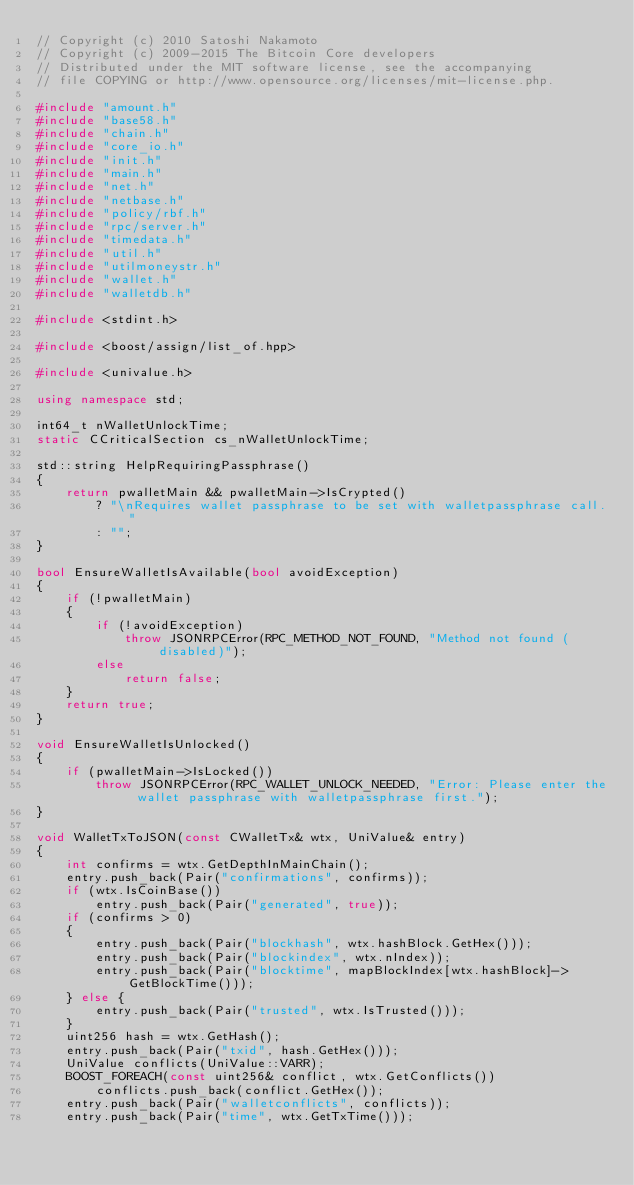<code> <loc_0><loc_0><loc_500><loc_500><_C++_>// Copyright (c) 2010 Satoshi Nakamoto
// Copyright (c) 2009-2015 The Bitcoin Core developers
// Distributed under the MIT software license, see the accompanying
// file COPYING or http://www.opensource.org/licenses/mit-license.php.

#include "amount.h"
#include "base58.h"
#include "chain.h"
#include "core_io.h"
#include "init.h"
#include "main.h"
#include "net.h"
#include "netbase.h"
#include "policy/rbf.h"
#include "rpc/server.h"
#include "timedata.h"
#include "util.h"
#include "utilmoneystr.h"
#include "wallet.h"
#include "walletdb.h"

#include <stdint.h>

#include <boost/assign/list_of.hpp>

#include <univalue.h>

using namespace std;

int64_t nWalletUnlockTime;
static CCriticalSection cs_nWalletUnlockTime;

std::string HelpRequiringPassphrase()
{
    return pwalletMain && pwalletMain->IsCrypted()
        ? "\nRequires wallet passphrase to be set with walletpassphrase call."
        : "";
}

bool EnsureWalletIsAvailable(bool avoidException)
{
    if (!pwalletMain)
    {
        if (!avoidException)
            throw JSONRPCError(RPC_METHOD_NOT_FOUND, "Method not found (disabled)");
        else
            return false;
    }
    return true;
}

void EnsureWalletIsUnlocked()
{
    if (pwalletMain->IsLocked())
        throw JSONRPCError(RPC_WALLET_UNLOCK_NEEDED, "Error: Please enter the wallet passphrase with walletpassphrase first.");
}

void WalletTxToJSON(const CWalletTx& wtx, UniValue& entry)
{
    int confirms = wtx.GetDepthInMainChain();
    entry.push_back(Pair("confirmations", confirms));
    if (wtx.IsCoinBase())
        entry.push_back(Pair("generated", true));
    if (confirms > 0)
    {
        entry.push_back(Pair("blockhash", wtx.hashBlock.GetHex()));
        entry.push_back(Pair("blockindex", wtx.nIndex));
        entry.push_back(Pair("blocktime", mapBlockIndex[wtx.hashBlock]->GetBlockTime()));
    } else {
        entry.push_back(Pair("trusted", wtx.IsTrusted()));
    }
    uint256 hash = wtx.GetHash();
    entry.push_back(Pair("txid", hash.GetHex()));
    UniValue conflicts(UniValue::VARR);
    BOOST_FOREACH(const uint256& conflict, wtx.GetConflicts())
        conflicts.push_back(conflict.GetHex());
    entry.push_back(Pair("walletconflicts", conflicts));
    entry.push_back(Pair("time", wtx.GetTxTime()));</code> 